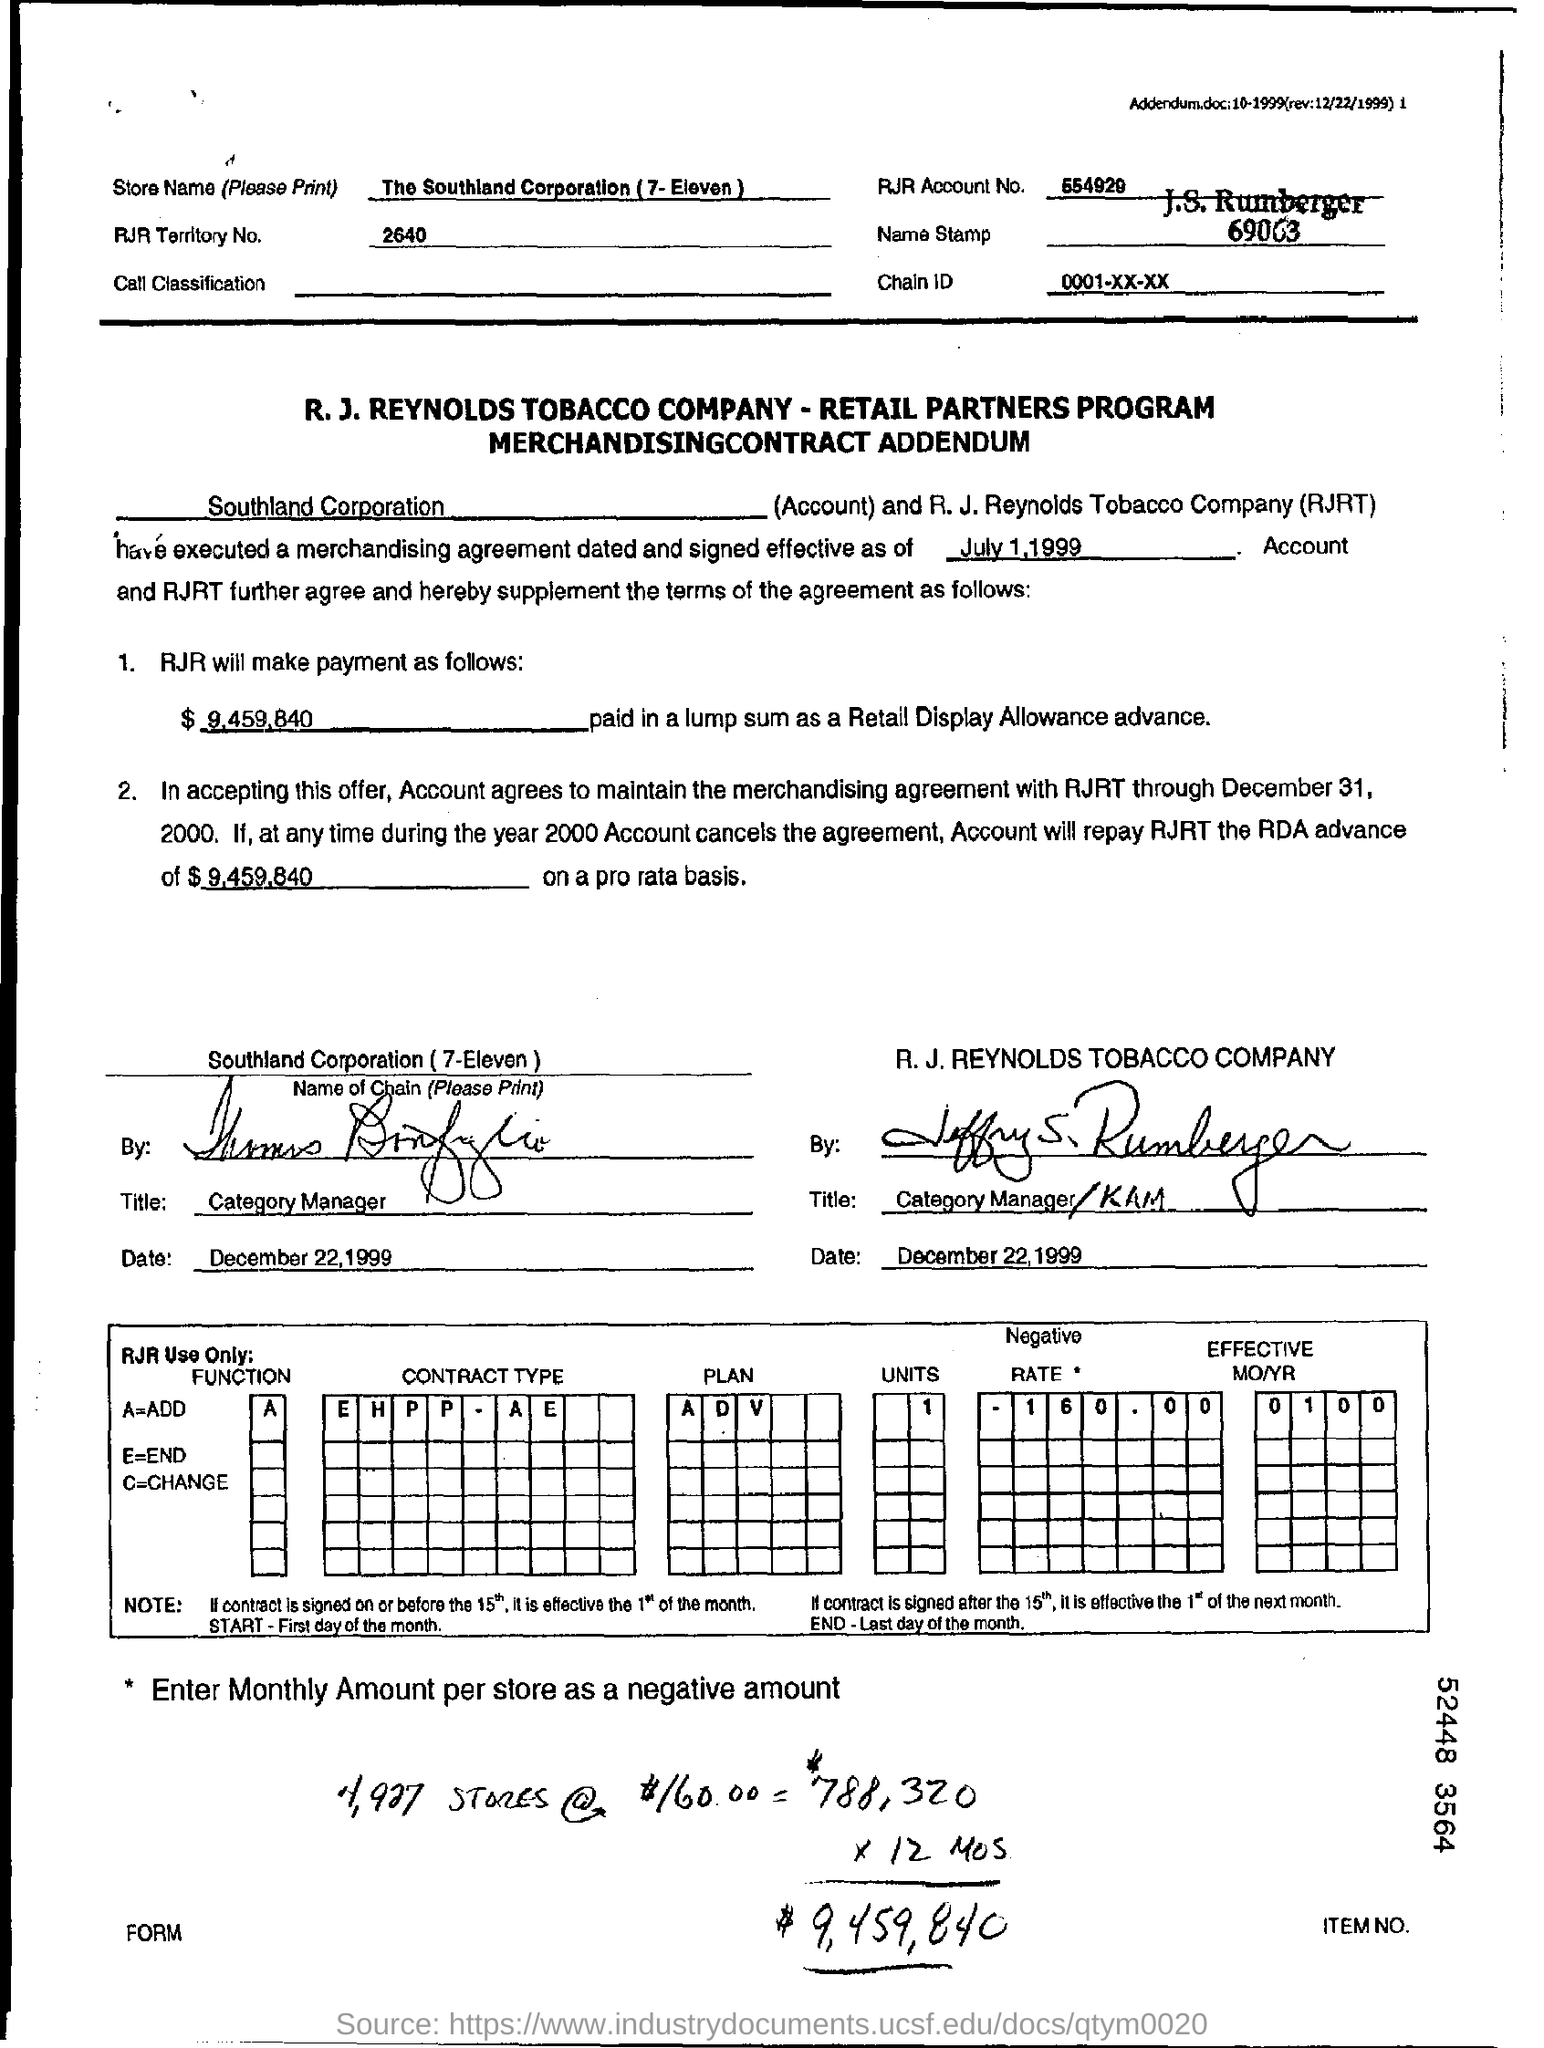What is the rjr territory no.?
Give a very brief answer. 2640. What is the rjr account no.?
Make the answer very short. 554929. What is a= ?
Give a very brief answer. ADD. What is e =?
Offer a terse response. End. What is the chain id mentioned in the form?
Give a very brief answer. 0001-XX-XX. How much will rjr pay in lump sum as a retail display allowance advance ?
Provide a short and direct response. $ 9,459,840. What is the store name ?
Ensure brevity in your answer.  The Southland Corporation. 